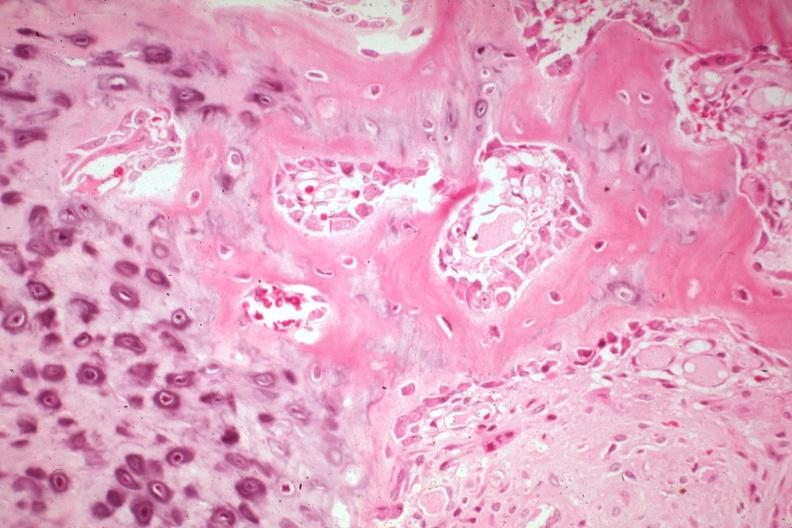what is present?
Answer the question using a single word or phrase. Joints 